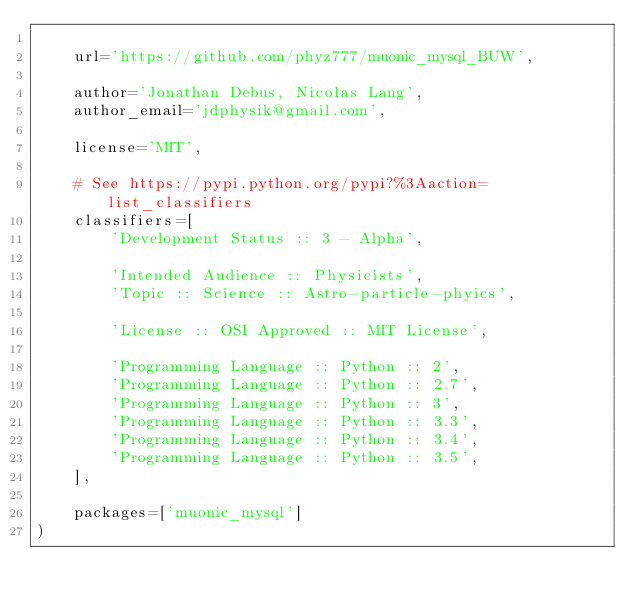Convert code to text. <code><loc_0><loc_0><loc_500><loc_500><_Python_>
    url='https://github.com/phyz777/muonic_mysql_BUW',

    author='Jonathan Debus, Nicolas Lang',
    author_email='jdphysik@gmail.com',

    license='MIT',

    # See https://pypi.python.org/pypi?%3Aaction=list_classifiers
    classifiers=[
        'Development Status :: 3 - Alpha',

        'Intended Audience :: Physicists',
        'Topic :: Science :: Astro-particle-phyics',

        'License :: OSI Approved :: MIT License',

        'Programming Language :: Python :: 2',
        'Programming Language :: Python :: 2.7',
        'Programming Language :: Python :: 3',
        'Programming Language :: Python :: 3.3',
        'Programming Language :: Python :: 3.4',
        'Programming Language :: Python :: 3.5',
    ],

    packages=['muonic_mysql']
)
</code> 